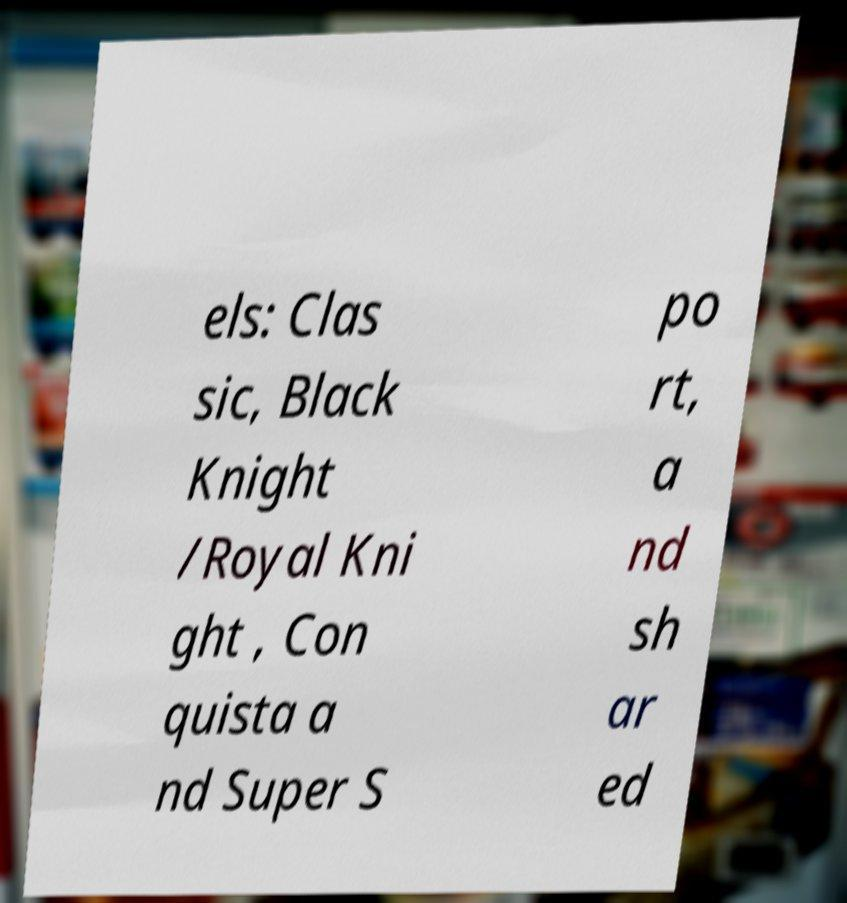Please read and relay the text visible in this image. What does it say? els: Clas sic, Black Knight /Royal Kni ght , Con quista a nd Super S po rt, a nd sh ar ed 